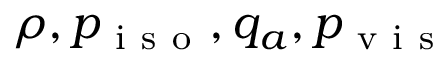Convert formula to latex. <formula><loc_0><loc_0><loc_500><loc_500>\rho , p _ { i s o } , q _ { a } , p _ { v i s }</formula> 